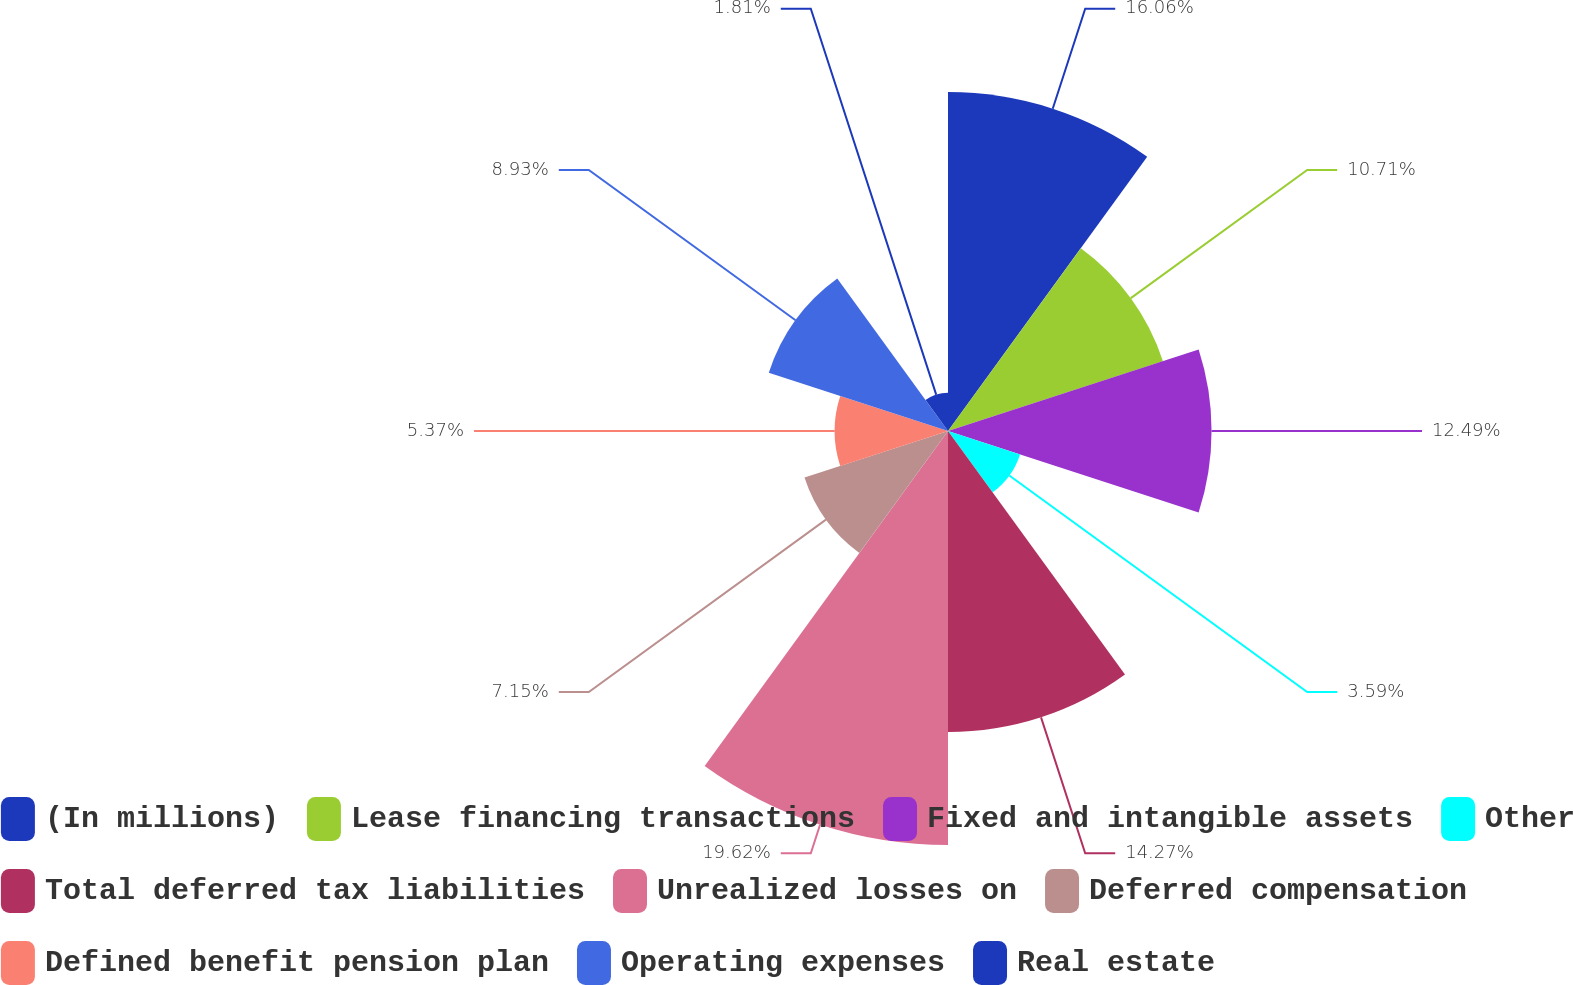Convert chart. <chart><loc_0><loc_0><loc_500><loc_500><pie_chart><fcel>(In millions)<fcel>Lease financing transactions<fcel>Fixed and intangible assets<fcel>Other<fcel>Total deferred tax liabilities<fcel>Unrealized losses on<fcel>Deferred compensation<fcel>Defined benefit pension plan<fcel>Operating expenses<fcel>Real estate<nl><fcel>16.06%<fcel>10.71%<fcel>12.49%<fcel>3.59%<fcel>14.27%<fcel>19.62%<fcel>7.15%<fcel>5.37%<fcel>8.93%<fcel>1.81%<nl></chart> 